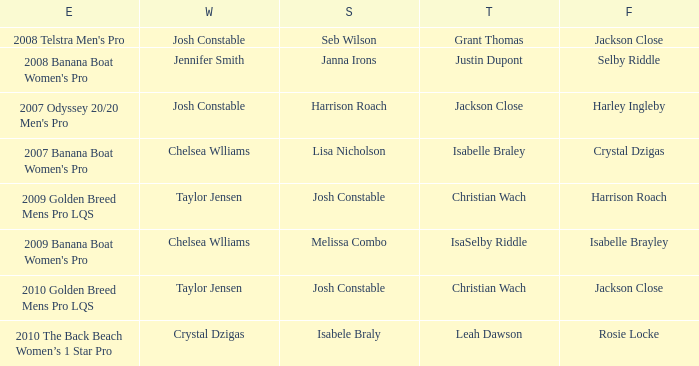Who ranked fourth in the 2008 telstra men's pro event? Jackson Close. 